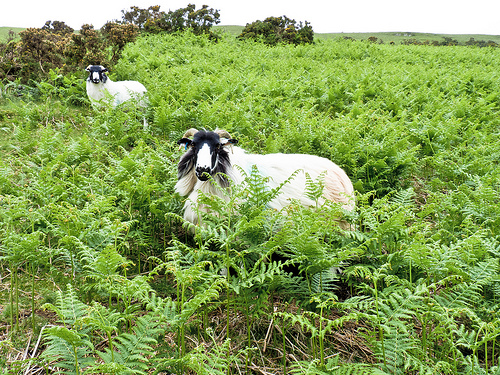Please provide a short description for this region: [0.0, 0.16, 0.27, 0.26]. Depicts a bush set subtly in the background, its dark foliage mingling with lighter green tones, creating a serene backdrop. 